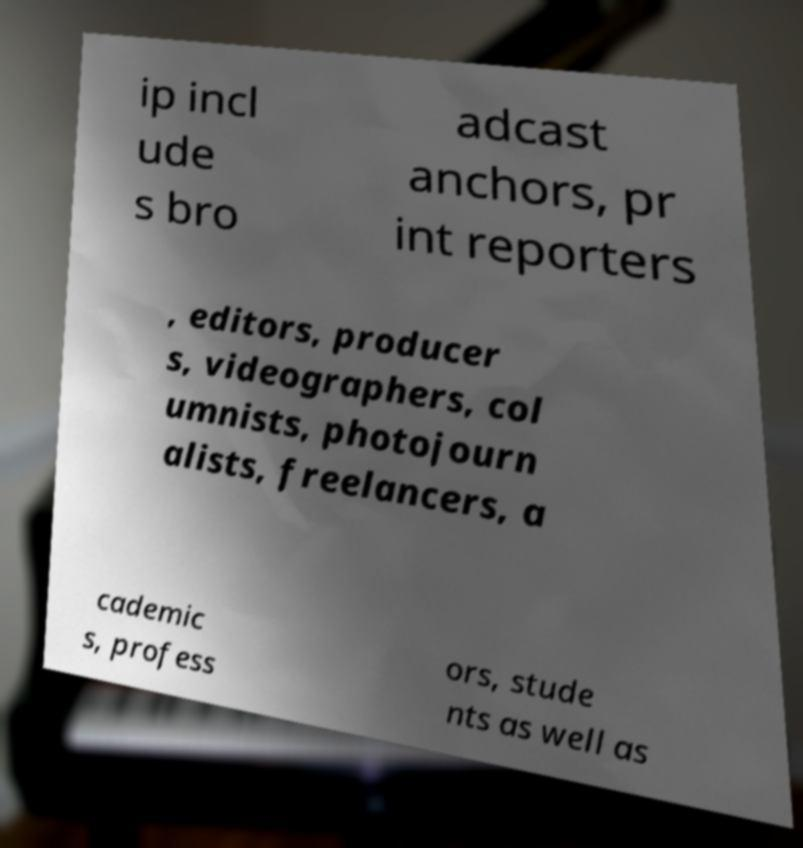What messages or text are displayed in this image? I need them in a readable, typed format. ip incl ude s bro adcast anchors, pr int reporters , editors, producer s, videographers, col umnists, photojourn alists, freelancers, a cademic s, profess ors, stude nts as well as 